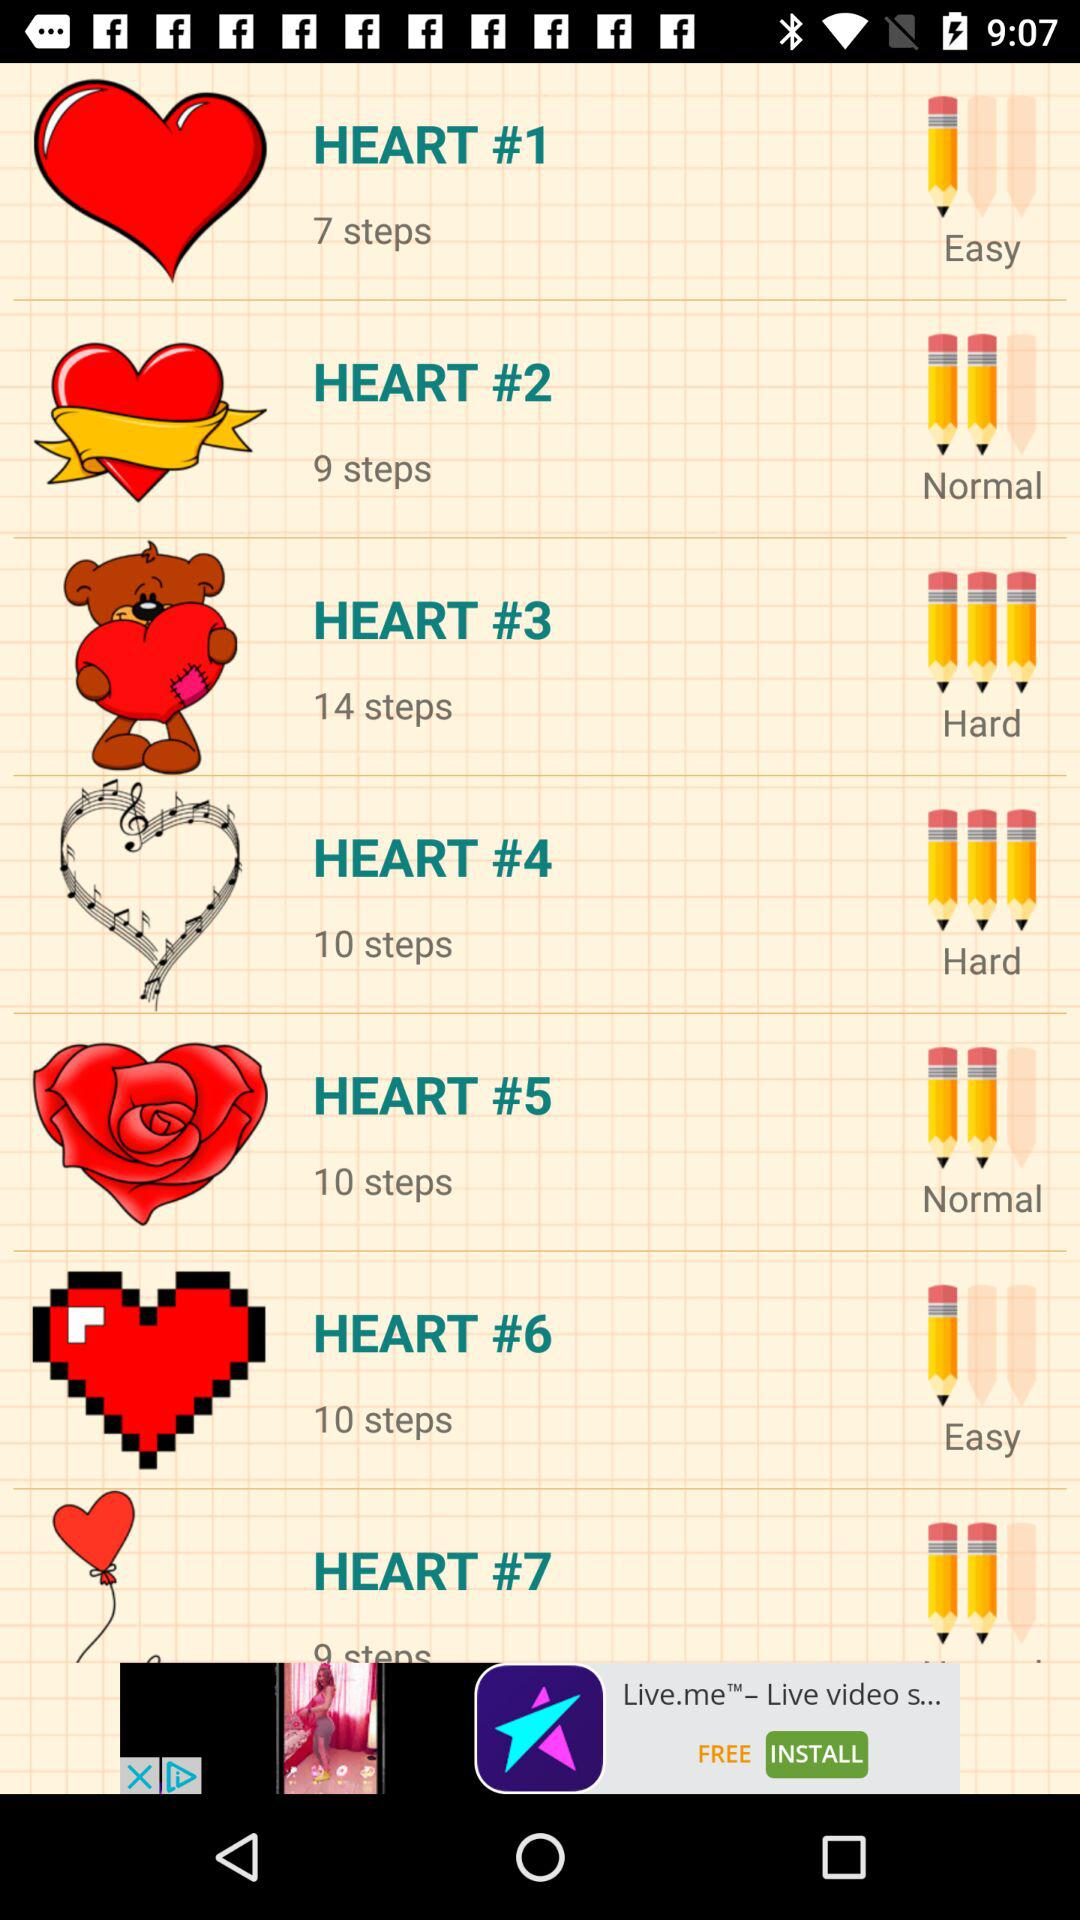How many steps are there in the hardest level?
Answer the question using a single word or phrase. 14 